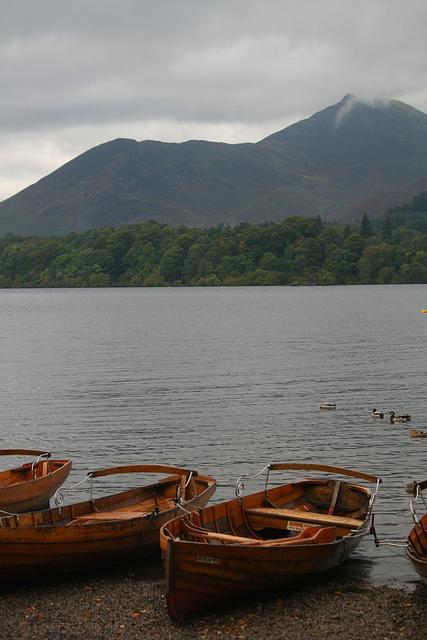How many boats are in the picture?
Give a very brief answer. 3. 